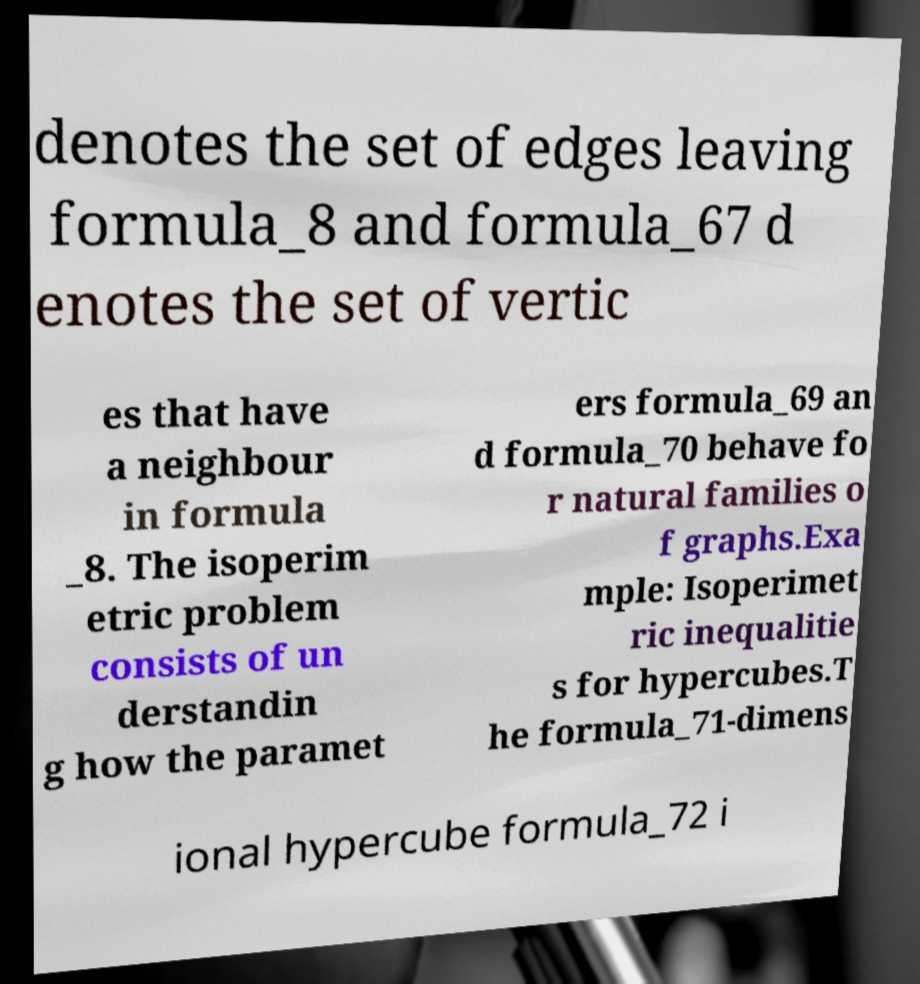There's text embedded in this image that I need extracted. Can you transcribe it verbatim? denotes the set of edges leaving formula_8 and formula_67 d enotes the set of vertic es that have a neighbour in formula _8. The isoperim etric problem consists of un derstandin g how the paramet ers formula_69 an d formula_70 behave fo r natural families o f graphs.Exa mple: Isoperimet ric inequalitie s for hypercubes.T he formula_71-dimens ional hypercube formula_72 i 